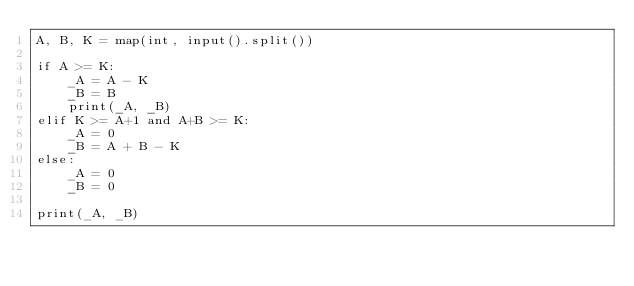Convert code to text. <code><loc_0><loc_0><loc_500><loc_500><_Python_>A, B, K = map(int, input().split())

if A >= K:
    _A = A - K
    _B = B
    print(_A, _B)
elif K >= A+1 and A+B >= K:
    _A = 0
    _B = A + B - K
else:
    _A = 0
    _B = 0

print(_A, _B)</code> 